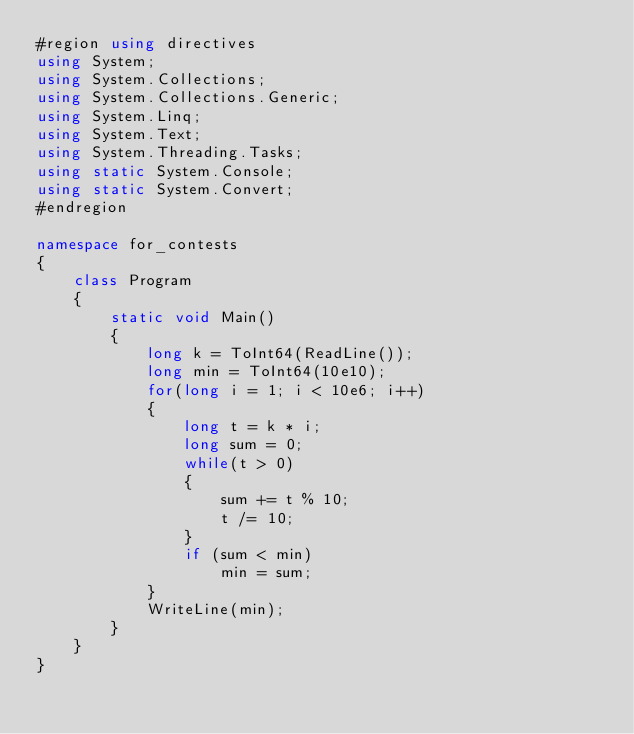<code> <loc_0><loc_0><loc_500><loc_500><_C#_>#region using directives
using System;
using System.Collections;
using System.Collections.Generic;
using System.Linq;
using System.Text;
using System.Threading.Tasks;
using static System.Console;
using static System.Convert;
#endregion

namespace for_contests
{
    class Program
    {
        static void Main()
        {
            long k = ToInt64(ReadLine());
            long min = ToInt64(10e10);
            for(long i = 1; i < 10e6; i++)
            {
                long t = k * i;
                long sum = 0;
                while(t > 0)
                {
                    sum += t % 10;
                    t /= 10;
                }
                if (sum < min)
                    min = sum;
            }
            WriteLine(min);
        }
    }
}
</code> 